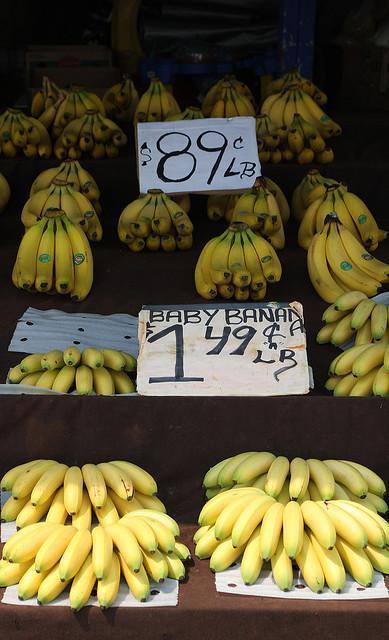How many bananas are in the photo?
Give a very brief answer. 9. How many people are sitting in the 4th row in the image?
Give a very brief answer. 0. 